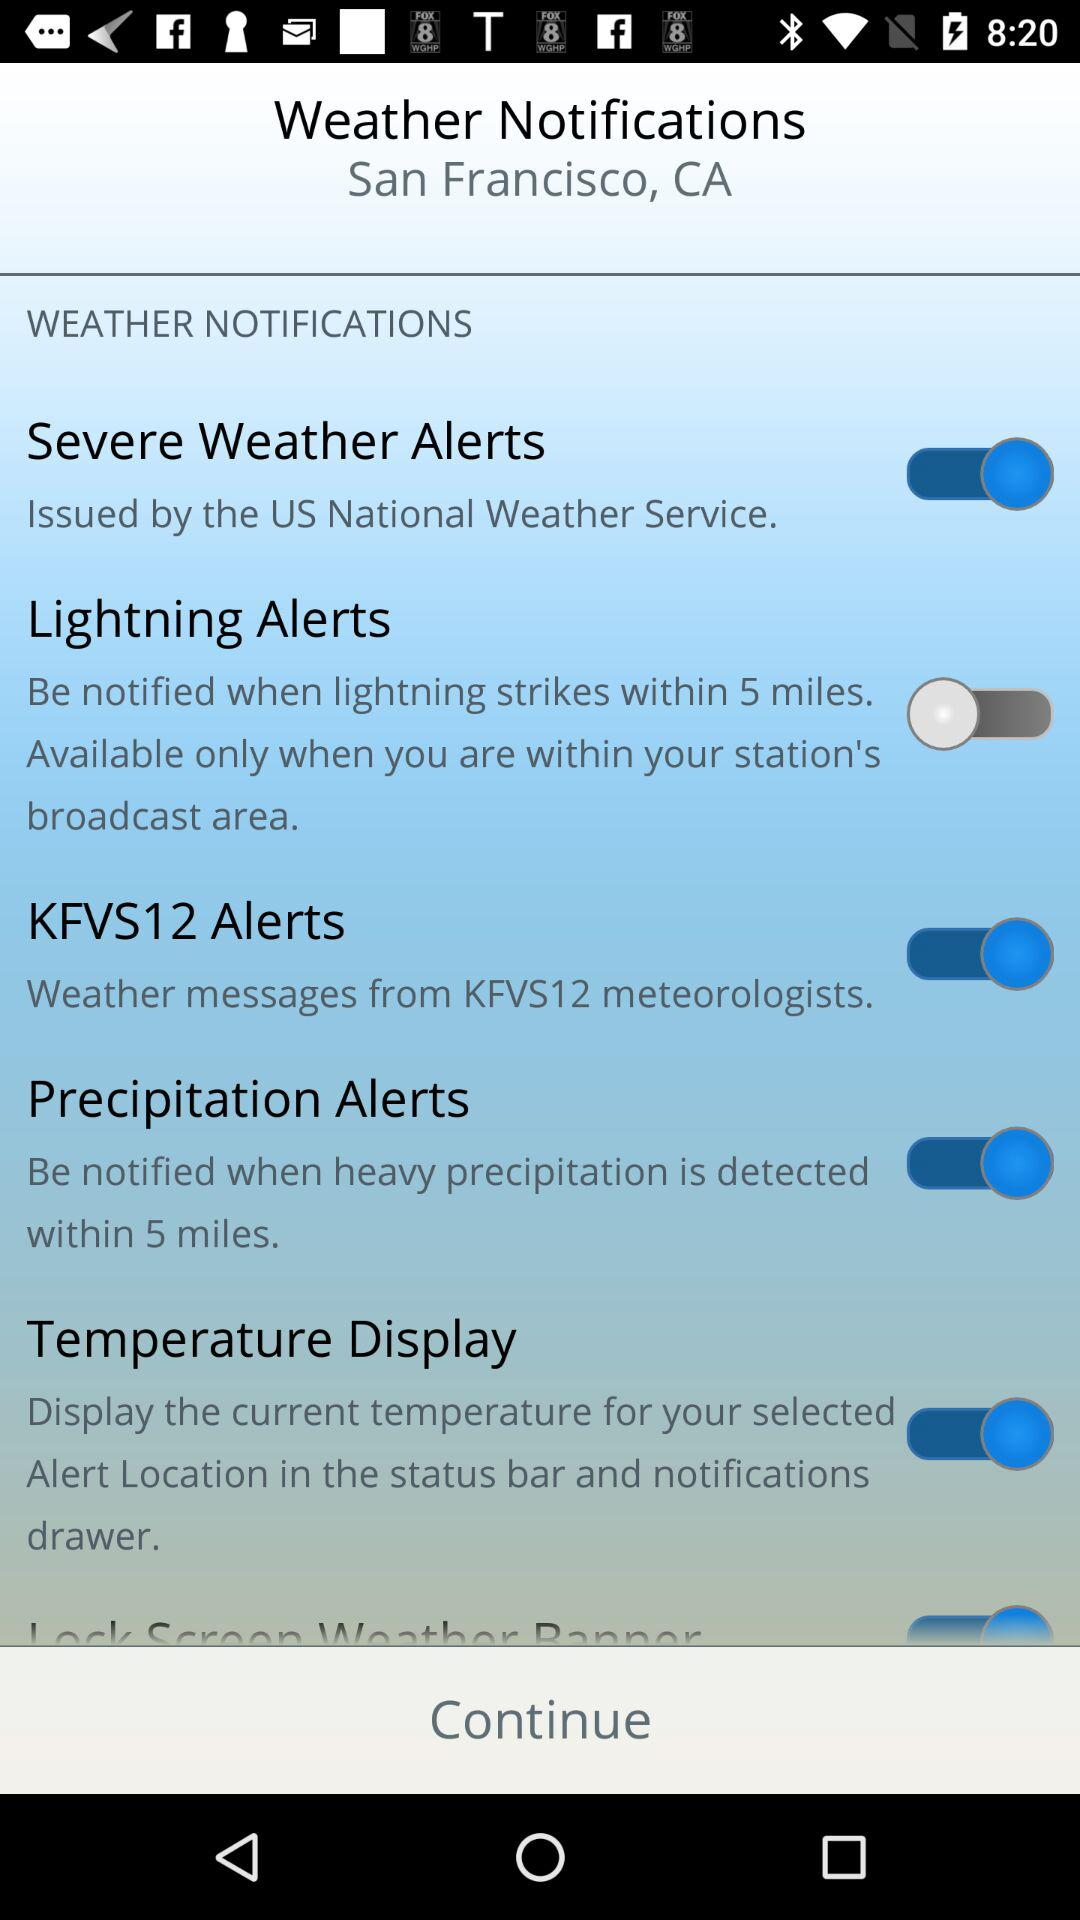What is the location? The location is San Francisco, CA. 